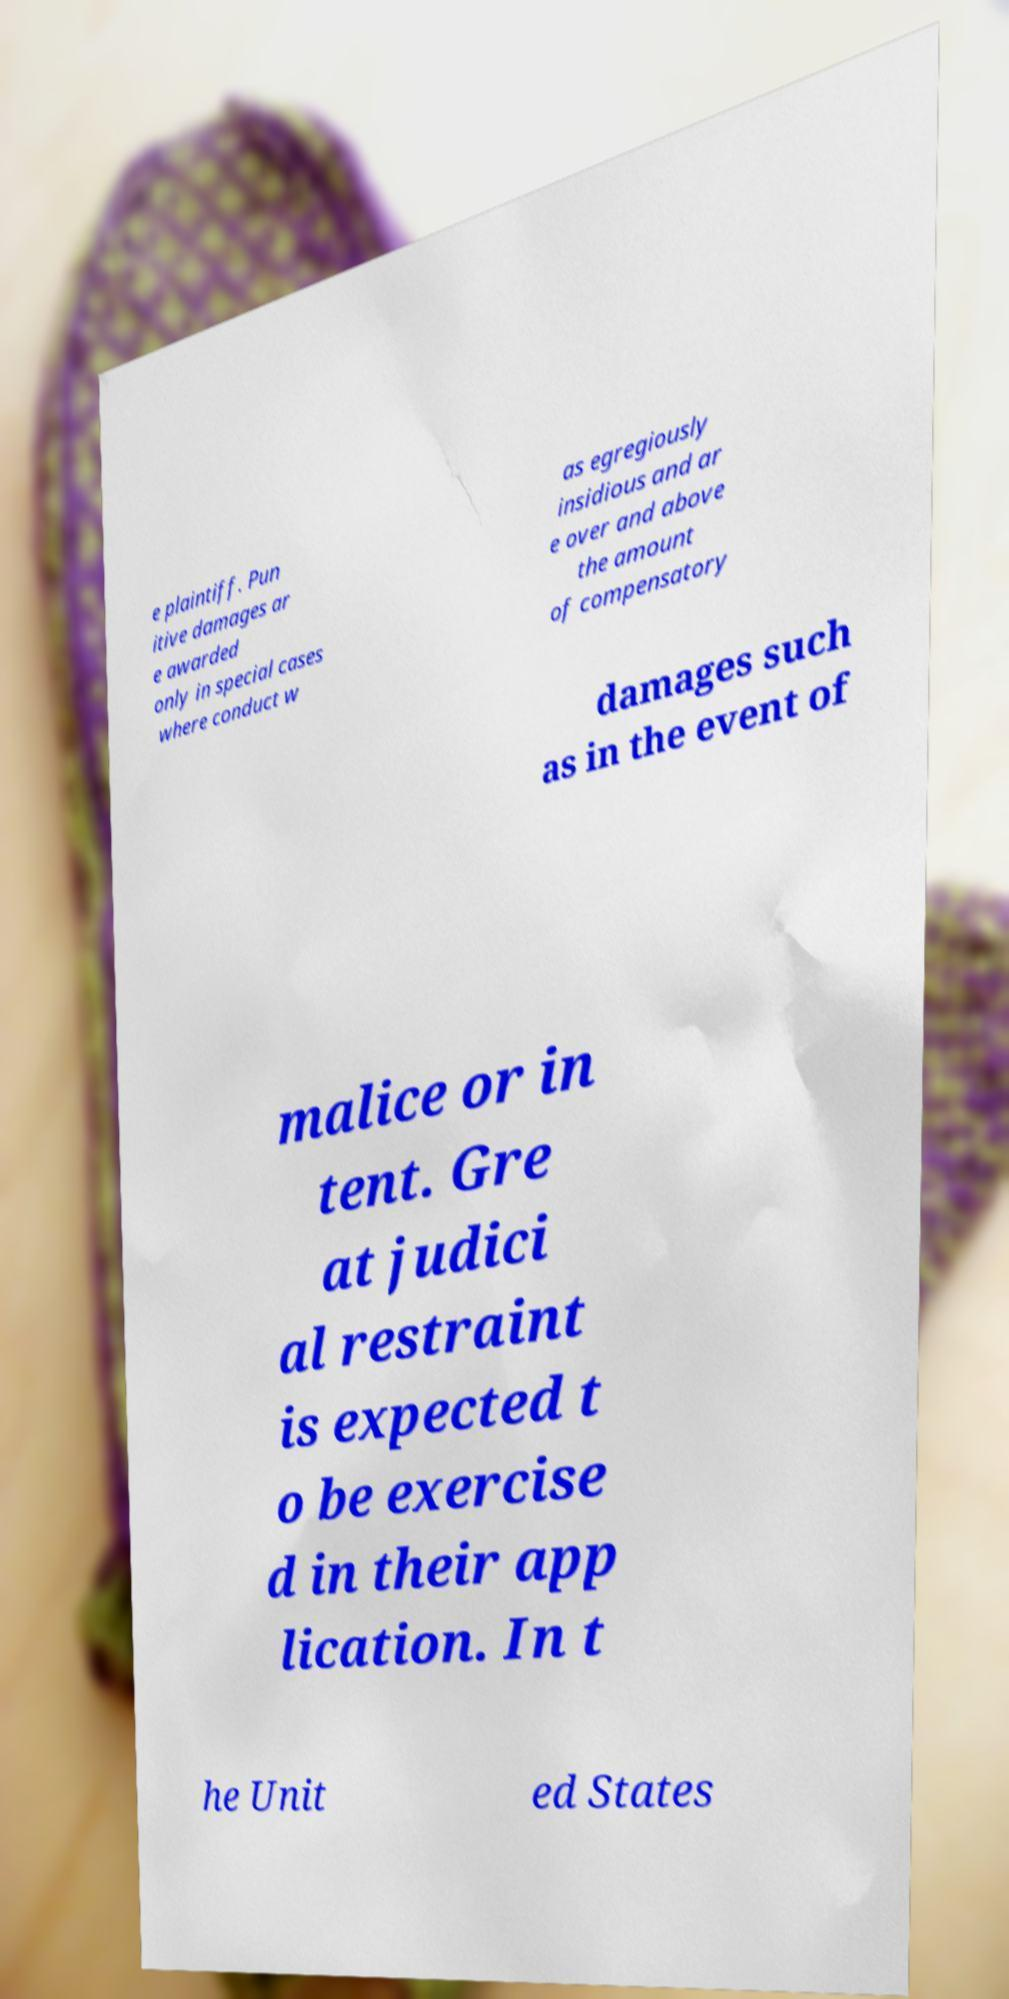Please identify and transcribe the text found in this image. e plaintiff. Pun itive damages ar e awarded only in special cases where conduct w as egregiously insidious and ar e over and above the amount of compensatory damages such as in the event of malice or in tent. Gre at judici al restraint is expected t o be exercise d in their app lication. In t he Unit ed States 